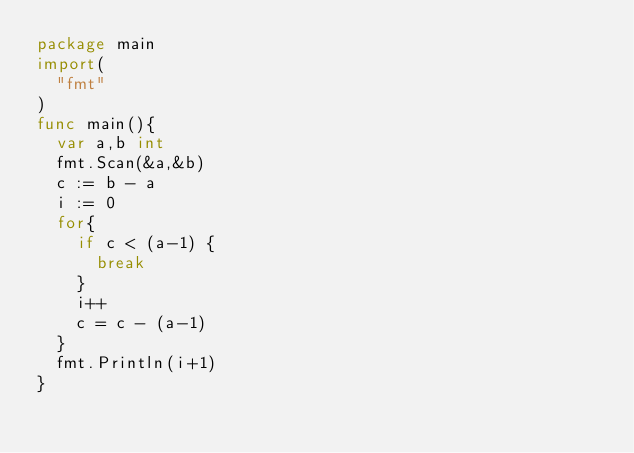Convert code to text. <code><loc_0><loc_0><loc_500><loc_500><_Go_>package main
import(
	"fmt"
)
func main(){
	var a,b int
	fmt.Scan(&a,&b)
	c := b - a
	i := 0
	for{
		if c < (a-1) {
			break
		}
		i++
		c = c - (a-1)
	}
	fmt.Println(i+1)
}</code> 